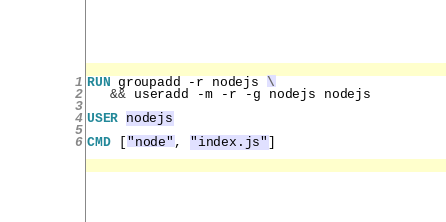Convert code to text. <code><loc_0><loc_0><loc_500><loc_500><_Dockerfile_>RUN groupadd -r nodejs \
   && useradd -m -r -g nodejs nodejs

USER nodejs

CMD ["node", "index.js"]
</code> 